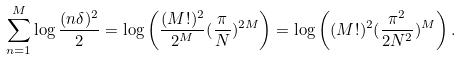<formula> <loc_0><loc_0><loc_500><loc_500>\sum ^ { M } _ { n = 1 } \log \frac { ( n \delta ) ^ { 2 } } { 2 } = \log \left ( \frac { ( M ! ) ^ { 2 } } { 2 ^ { M } } ( \frac { \pi } { N } ) ^ { 2 M } \right ) = \log \left ( ( M ! ) ^ { 2 } ( \frac { \pi ^ { 2 } } { 2 N ^ { 2 } } ) ^ { M } \right ) .</formula> 